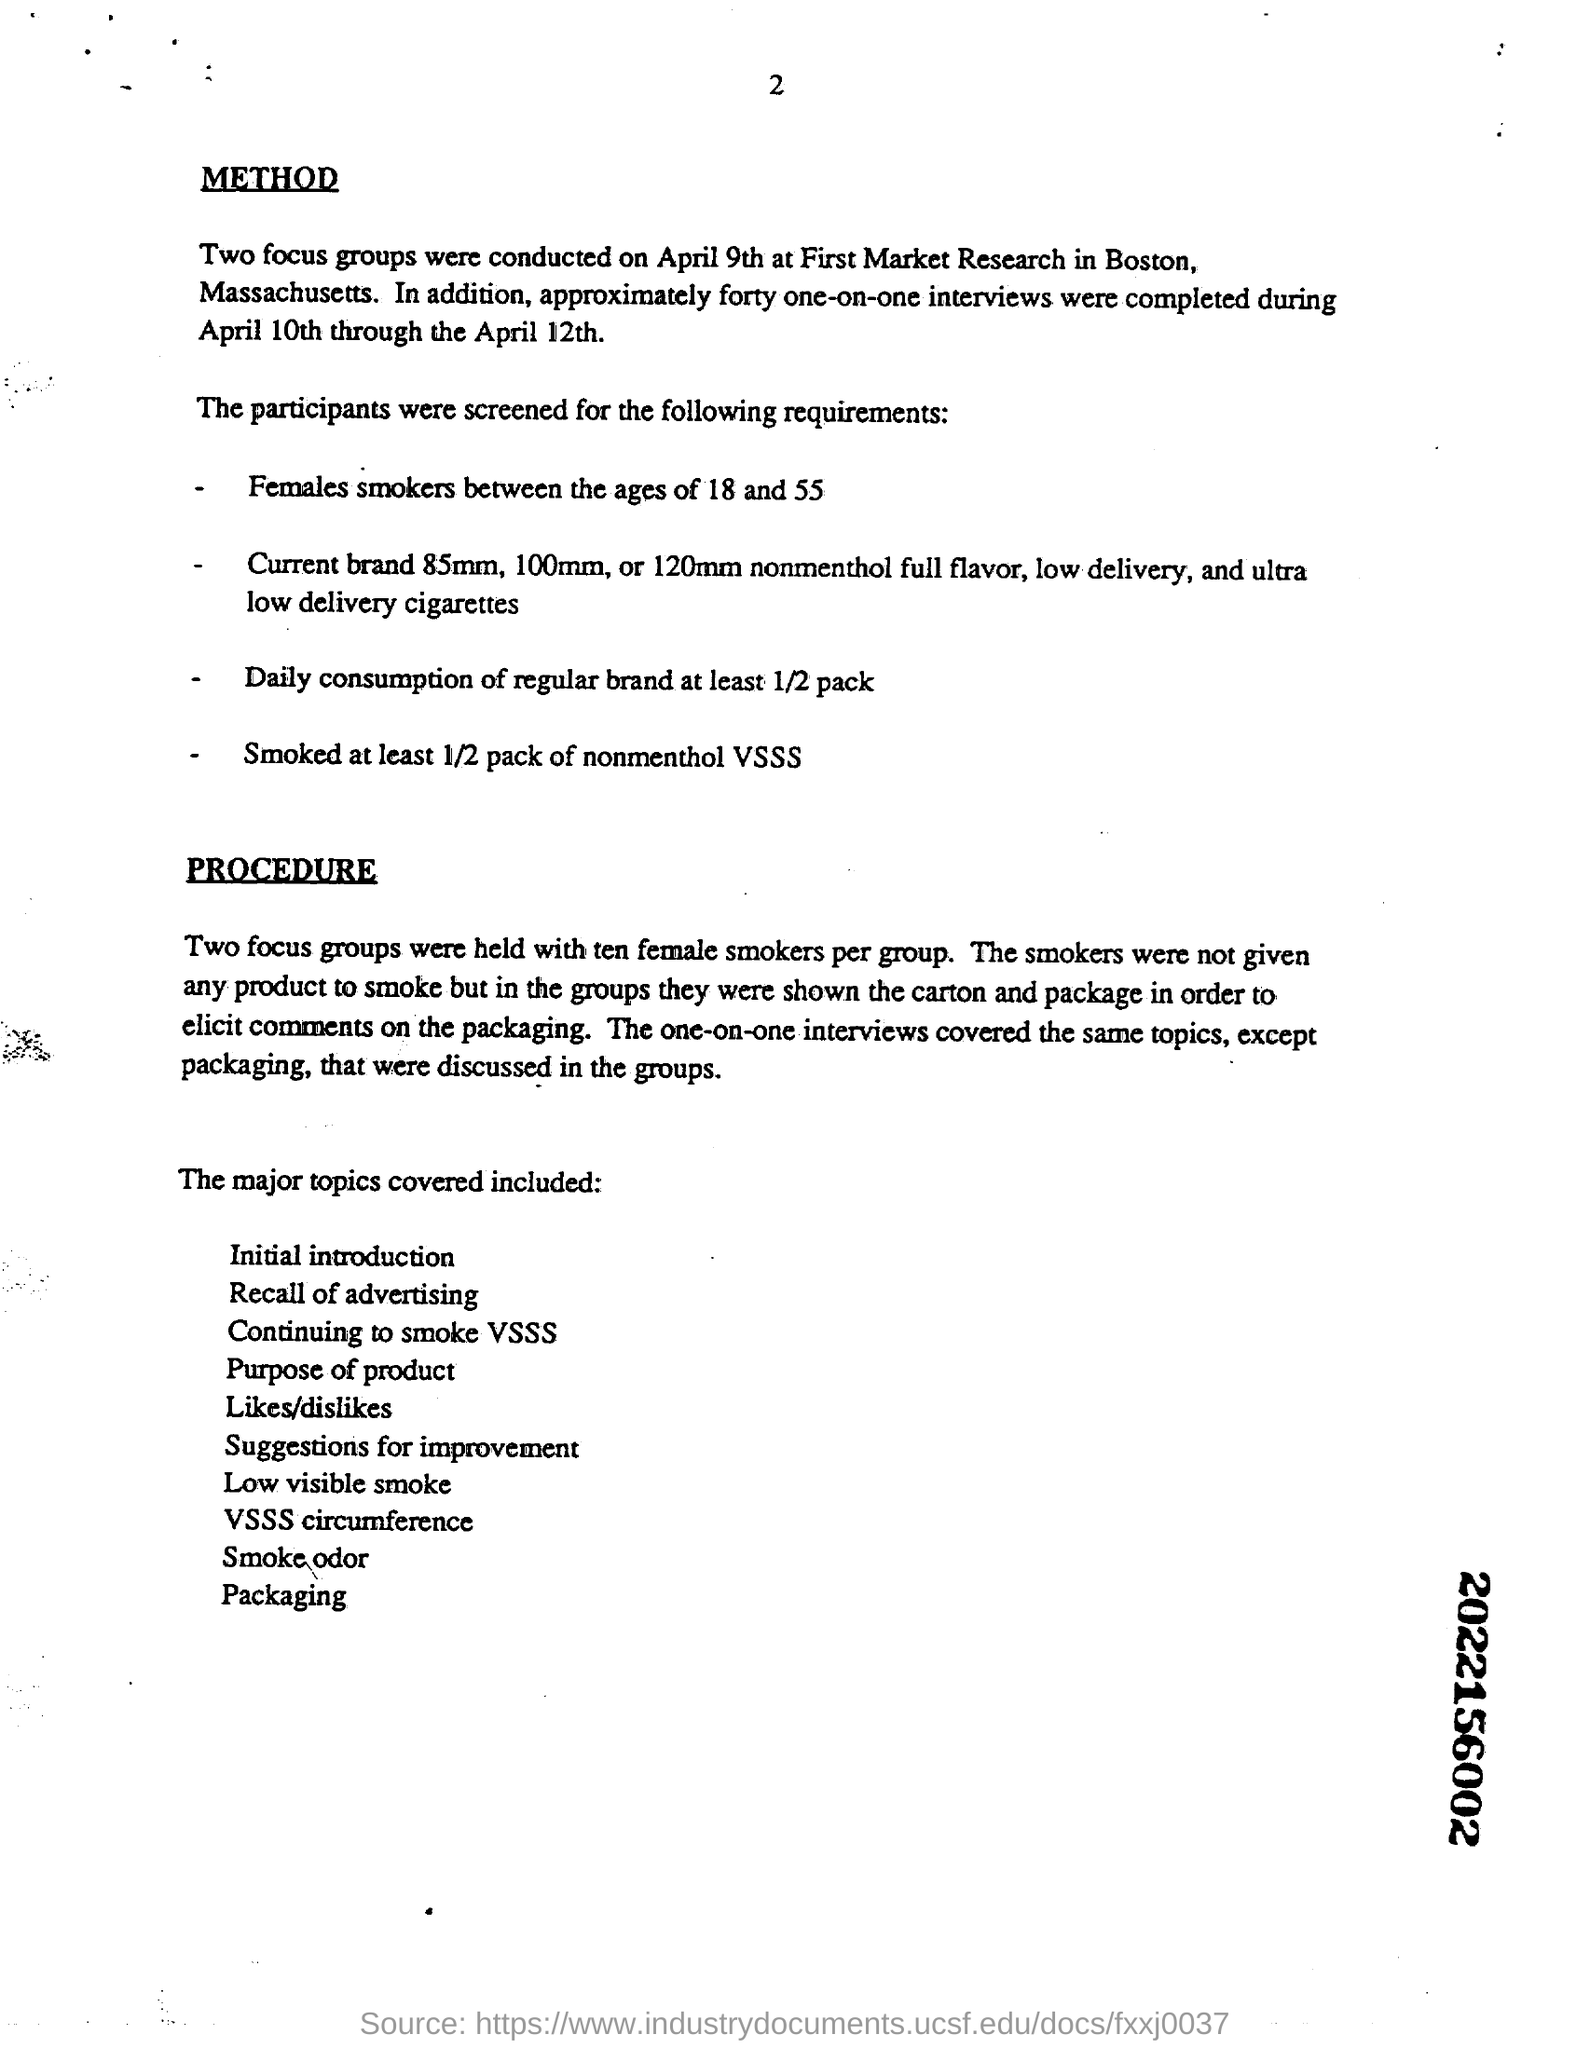What were the main topics discussed during the one-on-one interviews? The one-on-one interviews conducted in the study focused on a variety of topics related to smoking habits and perceptions. They included an initial introduction, recall of advertising, discussions on the choice to continue smoking VSSS, evaluation of likes and dislikes, understanding the purpose of the product, suggesting possible improvements, assessing perceptions related to low visible smoke, considering VSSS circumference, the impact of smoke odor, and opinions on packaging. 